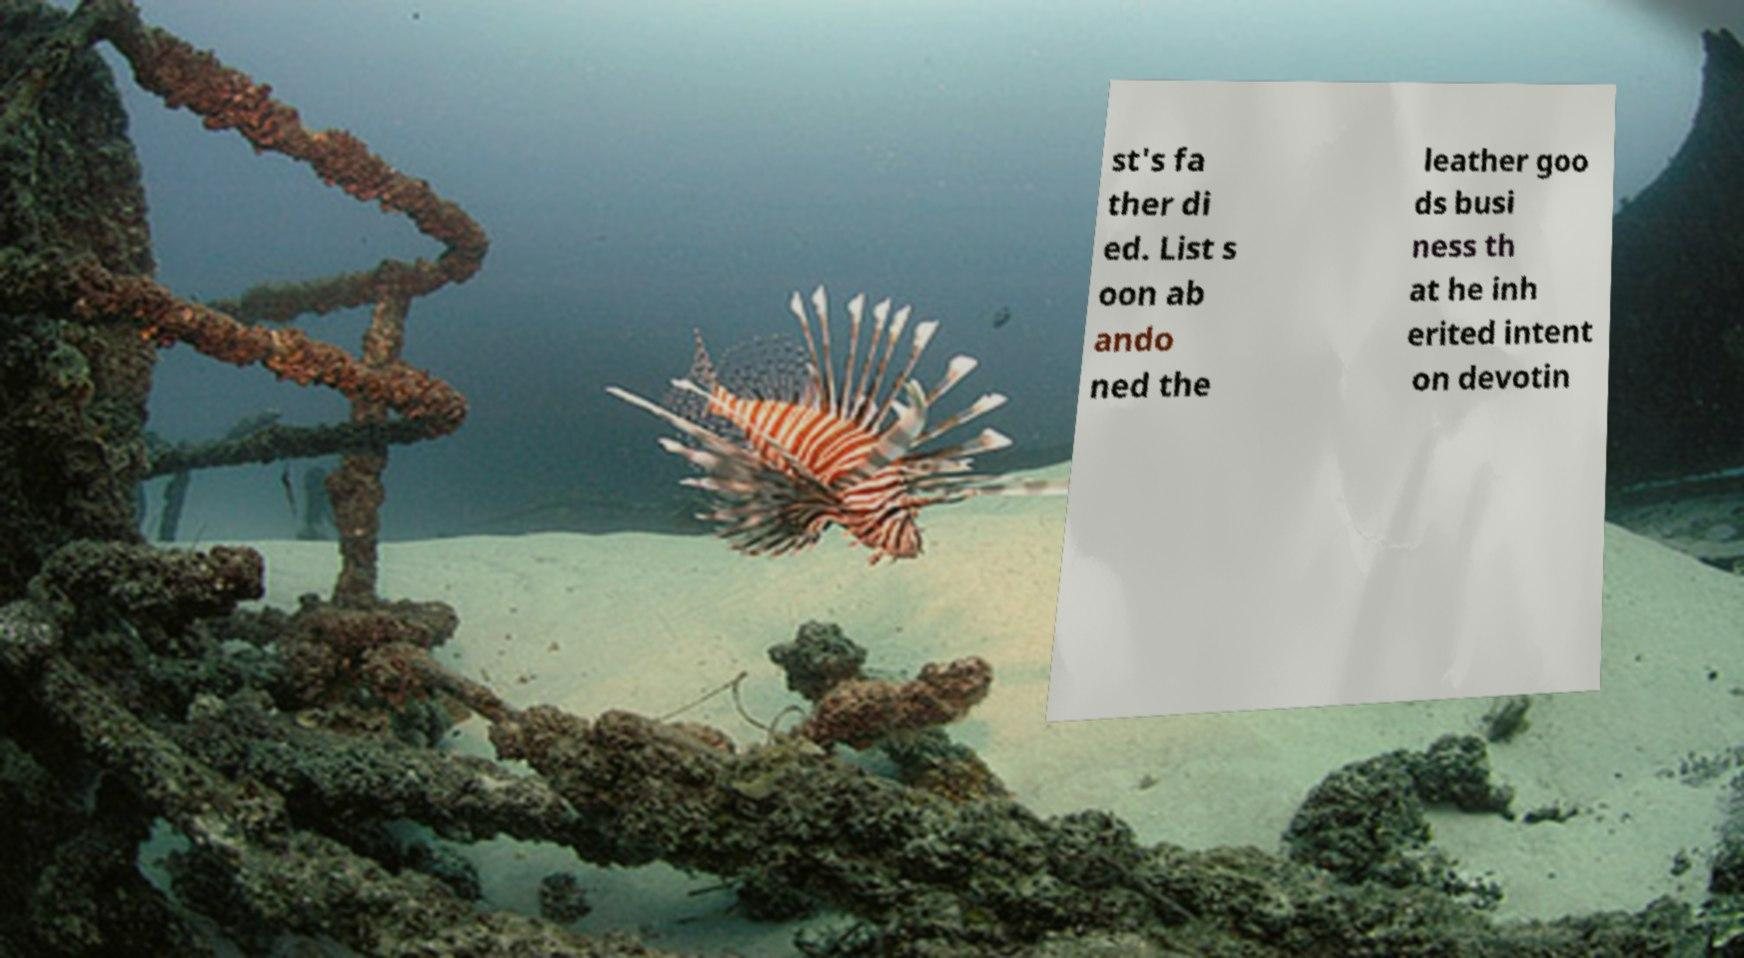What messages or text are displayed in this image? I need them in a readable, typed format. st's fa ther di ed. List s oon ab ando ned the leather goo ds busi ness th at he inh erited intent on devotin 